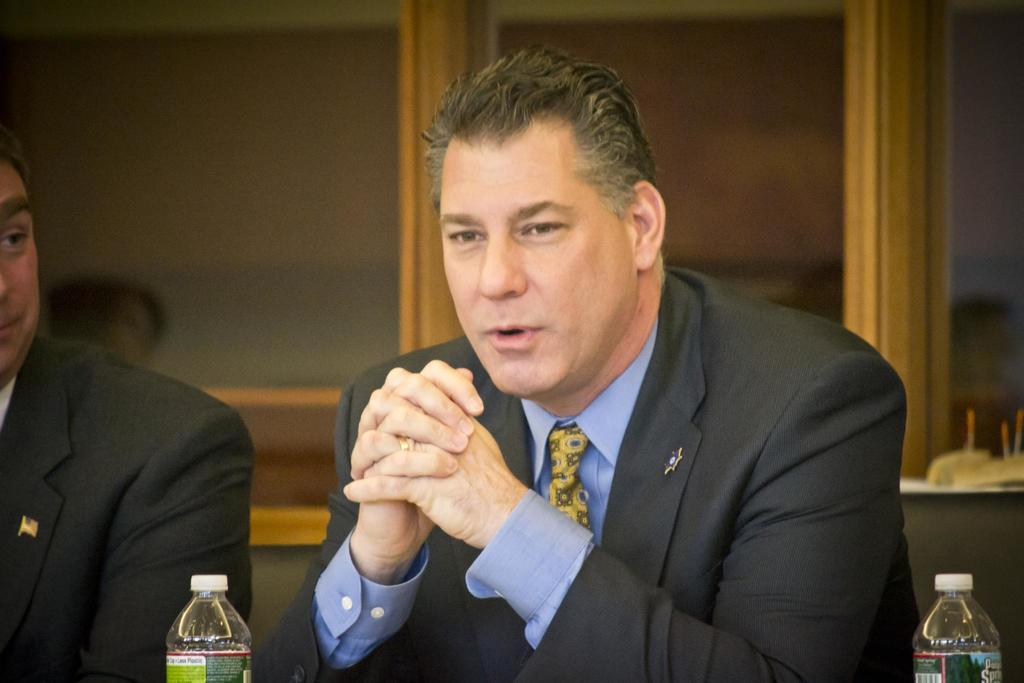What is the person in the image doing? The person is sitting in the image. What is the person wearing on their upper body? The person is wearing a black blazer, a blue shirt, and a green color tie. What objects are in front of the person? There are two bottles in front of the person. What can be seen in the background of the image? There are glass windows in the background of the image. What type of grain is visible on the person's shirt in the image? There is no grain visible on the person's shirt in the image. How many nails can be seen holding the shirt together in the image? There are no nails visible on the person's shirt in the image. 